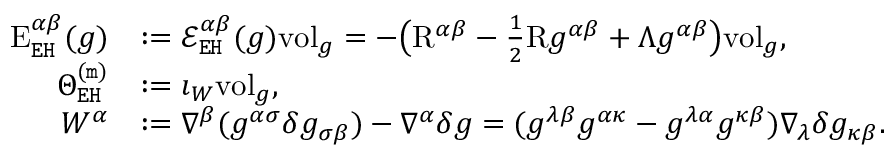<formula> <loc_0><loc_0><loc_500><loc_500>\begin{array} { r l } { E _ { E H } ^ { \alpha \beta } ( g ) } & { \colon = \mathcal { E } _ { E H } ^ { \alpha \beta } ( g ) v o l _ { g } = - \left ( R ^ { \alpha \beta } - \frac { 1 } { 2 } R g ^ { \alpha \beta } + \Lambda g ^ { \alpha \beta } \right ) v o l _ { g } , } \\ { \Theta _ { E H } ^ { ( m ) } } & { \colon = \imath _ { W } v o l _ { g } , } \\ { W ^ { \alpha } } & { \colon = \nabla ^ { \beta } ( g ^ { \alpha \sigma } \delta g _ { \sigma \beta } ) - \nabla ^ { \alpha } \delta g = ( g ^ { \lambda \beta } g ^ { \alpha \kappa } - g ^ { \lambda \alpha } g ^ { \kappa \beta } ) \nabla _ { \lambda } \delta g _ { \kappa \beta } . } \end{array}</formula> 